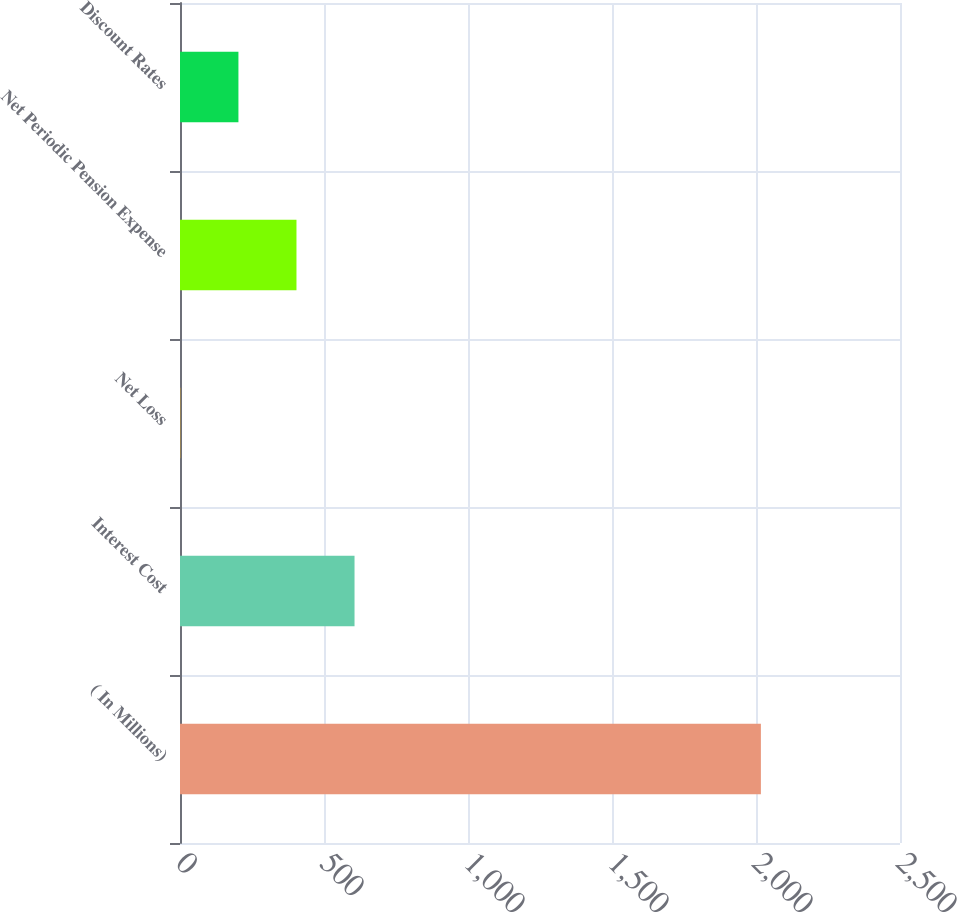<chart> <loc_0><loc_0><loc_500><loc_500><bar_chart><fcel>( In Millions)<fcel>Interest Cost<fcel>Net Loss<fcel>Net Periodic Pension Expense<fcel>Discount Rates<nl><fcel>2017<fcel>606.01<fcel>1.3<fcel>404.44<fcel>202.87<nl></chart> 